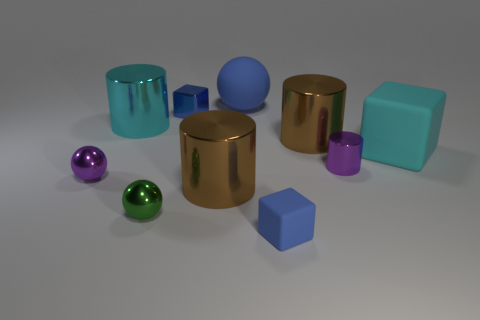What number of other objects are there of the same material as the small green object?
Provide a short and direct response. 6. Is the block that is in front of the big matte block made of the same material as the purple thing that is to the left of the small blue matte thing?
Ensure brevity in your answer.  No. The green metallic thing that is the same size as the blue matte cube is what shape?
Your answer should be compact. Sphere. Are there fewer tiny purple rubber cylinders than large matte objects?
Offer a terse response. Yes. Is there a big cyan metal object to the right of the tiny purple metallic object that is to the right of the small blue matte object?
Keep it short and to the point. No. Are there any large cyan metal cylinders that are in front of the tiny metal thing right of the tiny blue object that is in front of the large cyan shiny object?
Provide a succinct answer. No. Is the shape of the big matte thing that is behind the big block the same as the big brown metal thing in front of the tiny purple ball?
Your answer should be very brief. No. There is a block that is the same material as the purple sphere; what color is it?
Keep it short and to the point. Blue. Is the number of large cyan cylinders behind the blue shiny block less than the number of metal objects?
Give a very brief answer. Yes. There is a metal cylinder that is to the right of the brown metal cylinder that is behind the cyan object on the right side of the tiny green thing; how big is it?
Provide a succinct answer. Small. 